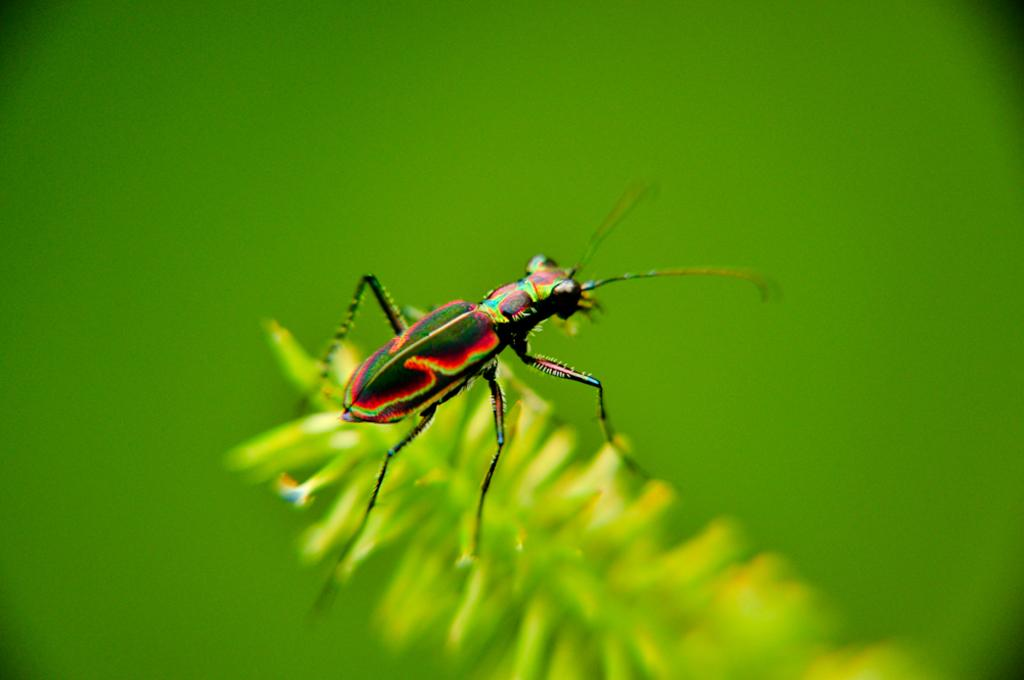What type of creature can be seen on the leaves in the image? There is a small insect on the leaves in the image. What is the dominant color in the background of the image? The background of the image has a green color. What type of observation can be made about the quicksand in the image? There is no quicksand present in the image; it features a small insect on leaves with a green background. 